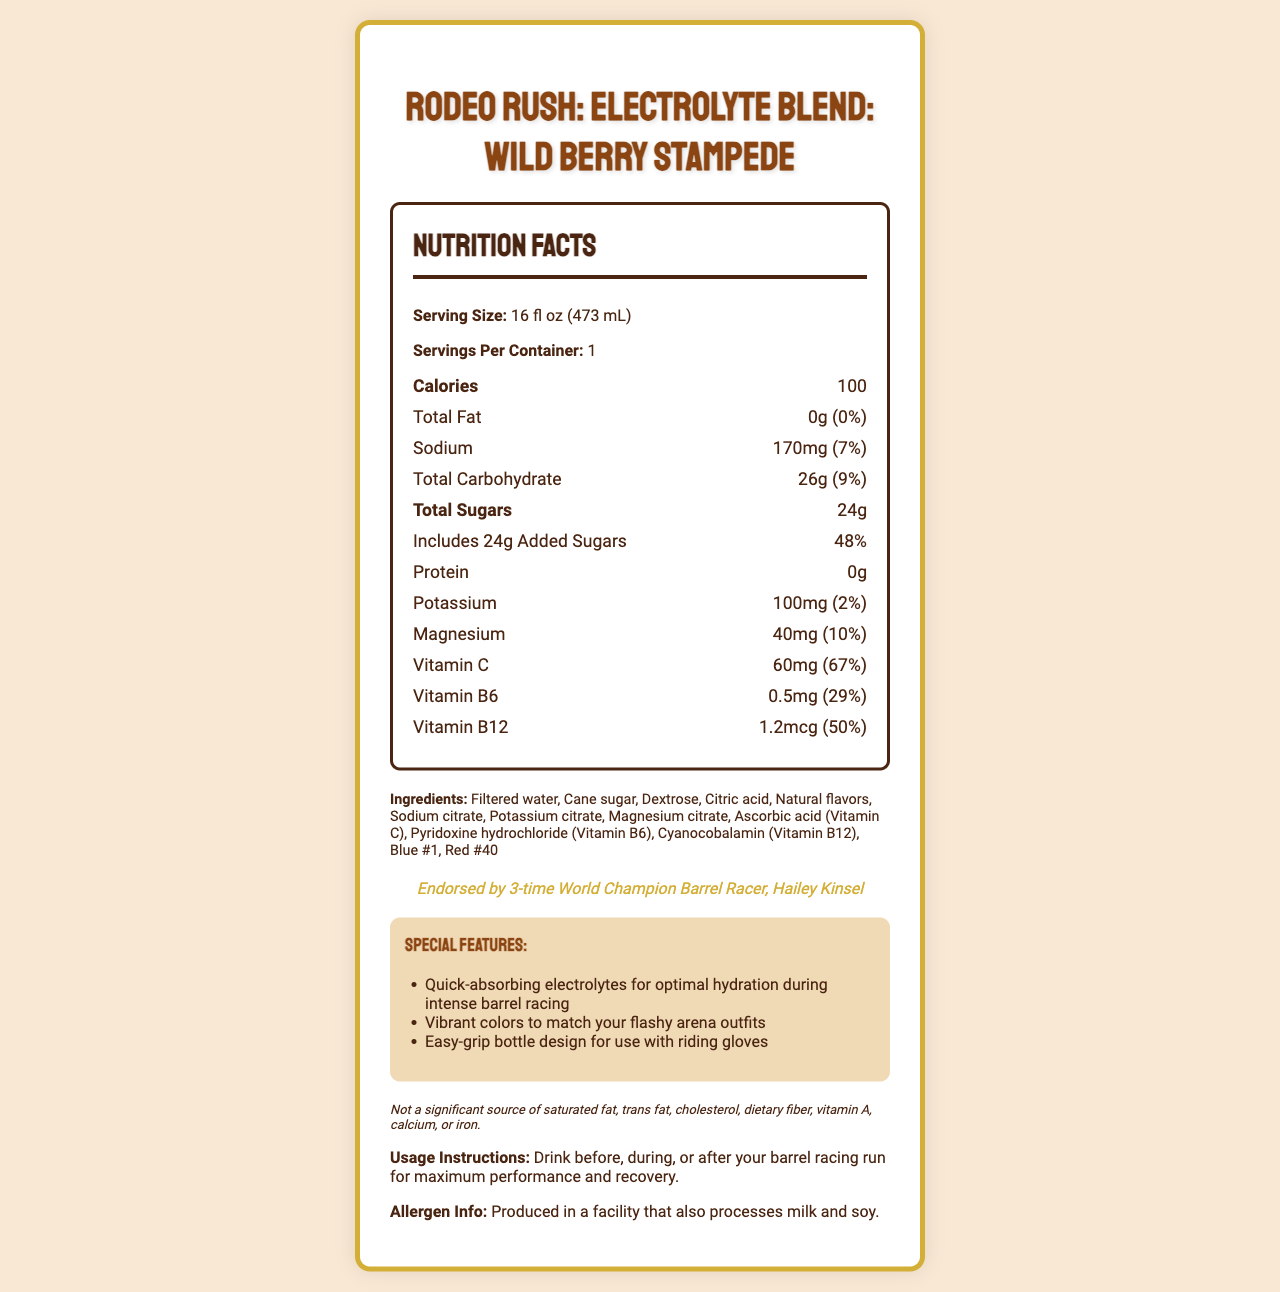what is the serving size for Rodeo Rush: Electrolyte Blend? The serving size is listed at the top of the Nutrition Facts section.
Answer: 16 fl oz (473 mL) How many calories are in one serving of Rodeo Rush: Electrolyte Blend? The calories content is directly listed under the Nutrition Facts with large, bold numbers.
Answer: 100 What percentage of the daily value for sodium does one serving contain? The sodium content section mentions 170mg, which is 7% of the daily value.
Answer: 7% How many grams of total sugars are in Rodeo Rush: Electrolyte Blend? The total sugars are mentioned beneath the total carbohydrate section as 24 grams.
Answer: 24g How much magnesium is provided in one serving? The magnesium content is listed as 40mg, providing 10% of the daily value.
Answer: 40mg Which vitamin has the highest daily value percentage in Rodeo Rush: Electrolyte Blend? Vitamin C is listed as 60mg with 67% of daily value, which is the highest among the listed vitamins and minerals.
Answer: Vitamin C What are the main ingredients used in Rodeo Rush: Electrolyte Blend? A. Cane sugar, Dextrose, Citric acid B. Filtered water, Cane sugar, Natural flavors C. Blue #1, Red #40, Sodium citrate The main ingredients listed first are Filtered water, Cane sugar, and Natural flavors.
Answer: B How is Rodeo Rush: Electrolyte Blend endorsed on the label? A. By a famous cowgirl B. By a nutritionist C. By a sports association The label mentions that it is "Endorsed by 3-time World Champion Barrel Racer, Hailey Kinsel."
Answer: A Are there any allergens mentioned in the document? The allergen info states that it is produced in a facility that also processes milk and soy.
Answer: Yes Can the product’s nutritional impact on calcium levels be determined from this document? The document explicitly states that it is not a significant source of calcium, and no specific calcium content is mentioned.
Answer: No Describe the key features and nutritional content of the Rodeo Rush: Electrolyte Blend as presented in the document. This summary provides a comprehensive overview of the nutritional facts, key features, and additional information about the product as presented in the document.
Answer: Rodeo Rush: Electrolyte Blend is a fruit-flavored sports drink formulated for barrel racers, consisting of 16 fl oz per serving and providing 100 calories. It contains 0g total fat, 170mg of sodium (7% daily value), 26g total carbohydrates (9% daily value), 24g total sugars (including 24g added sugars - 48% daily value), and 0g protein. Notable vitamins and minerals include 100mg potassium (2% daily value), 40mg magnesium (10% daily value), 60mg vitamin C (67% daily value), 0.5mg vitamin B6 (29% daily value), and 1.2mcg vitamin B12 (50% daily value). The drink features quick-absorbing electrolytes, vibrant colors, and an easy-grip bottle for riding gloves. It also mentions allergen information and specific endorsement by World Champion Barrel Racer, Hailey Kinsel. 